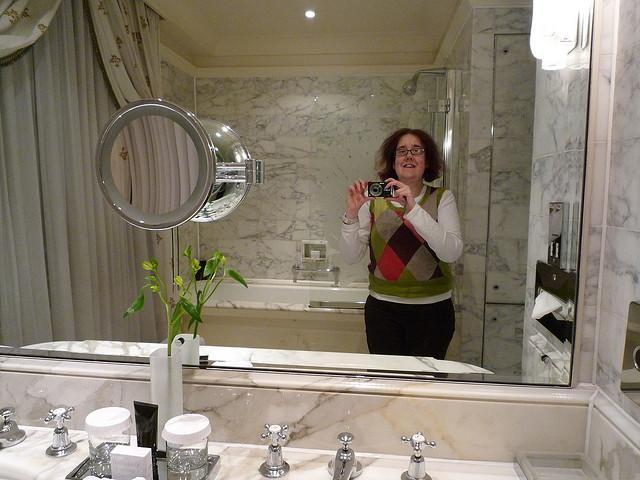What type of shower head is in the background? Please explain your reasoning. wall mount. The shower head is mounted to the wall. 